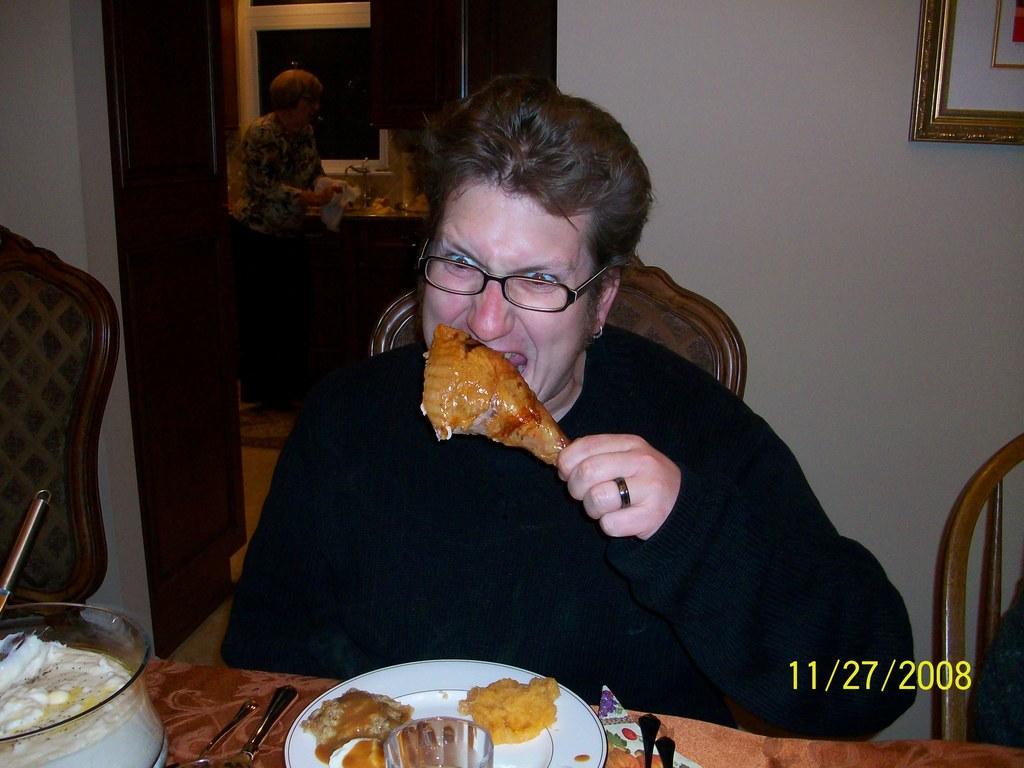Could you give a brief overview of what you see in this image? The picture is taken in a house. In the foreground of the picture there is a woman sitting and eating. In front of her there is a table, on the table there are plates, bowls, spoons and various food items. In the center of the picture there are chairs. In the background there is a woman, in the kitchen. On the left there is a door. On the right there is a frame. 